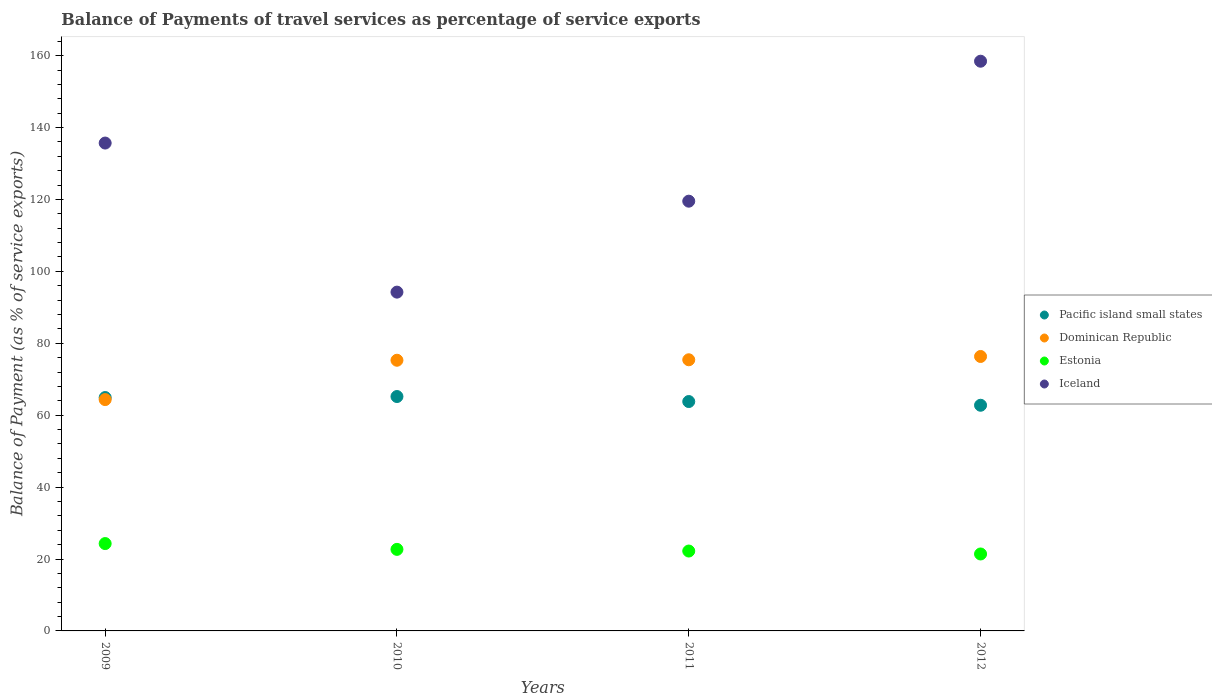Is the number of dotlines equal to the number of legend labels?
Your answer should be very brief. Yes. What is the balance of payments of travel services in Pacific island small states in 2012?
Your answer should be very brief. 62.76. Across all years, what is the maximum balance of payments of travel services in Pacific island small states?
Give a very brief answer. 65.19. Across all years, what is the minimum balance of payments of travel services in Dominican Republic?
Provide a succinct answer. 64.34. What is the total balance of payments of travel services in Estonia in the graph?
Provide a short and direct response. 90.59. What is the difference between the balance of payments of travel services in Pacific island small states in 2009 and that in 2011?
Make the answer very short. 1.11. What is the difference between the balance of payments of travel services in Pacific island small states in 2010 and the balance of payments of travel services in Iceland in 2009?
Make the answer very short. -70.5. What is the average balance of payments of travel services in Estonia per year?
Your answer should be compact. 22.65. In the year 2011, what is the difference between the balance of payments of travel services in Pacific island small states and balance of payments of travel services in Estonia?
Give a very brief answer. 41.58. In how many years, is the balance of payments of travel services in Estonia greater than 64 %?
Provide a short and direct response. 0. What is the ratio of the balance of payments of travel services in Dominican Republic in 2010 to that in 2011?
Give a very brief answer. 1. Is the balance of payments of travel services in Estonia in 2010 less than that in 2012?
Your answer should be very brief. No. What is the difference between the highest and the second highest balance of payments of travel services in Iceland?
Offer a terse response. 22.76. What is the difference between the highest and the lowest balance of payments of travel services in Pacific island small states?
Provide a short and direct response. 2.43. In how many years, is the balance of payments of travel services in Iceland greater than the average balance of payments of travel services in Iceland taken over all years?
Ensure brevity in your answer.  2. Is the sum of the balance of payments of travel services in Iceland in 2009 and 2012 greater than the maximum balance of payments of travel services in Dominican Republic across all years?
Provide a succinct answer. Yes. Is it the case that in every year, the sum of the balance of payments of travel services in Iceland and balance of payments of travel services in Estonia  is greater than the sum of balance of payments of travel services in Dominican Republic and balance of payments of travel services in Pacific island small states?
Your answer should be very brief. Yes. Is it the case that in every year, the sum of the balance of payments of travel services in Dominican Republic and balance of payments of travel services in Pacific island small states  is greater than the balance of payments of travel services in Iceland?
Your answer should be very brief. No. Does the balance of payments of travel services in Pacific island small states monotonically increase over the years?
Provide a succinct answer. No. Is the balance of payments of travel services in Dominican Republic strictly greater than the balance of payments of travel services in Estonia over the years?
Your answer should be very brief. Yes. What is the difference between two consecutive major ticks on the Y-axis?
Make the answer very short. 20. Where does the legend appear in the graph?
Keep it short and to the point. Center right. What is the title of the graph?
Ensure brevity in your answer.  Balance of Payments of travel services as percentage of service exports. What is the label or title of the Y-axis?
Offer a very short reply. Balance of Payment (as % of service exports). What is the Balance of Payment (as % of service exports) in Pacific island small states in 2009?
Your response must be concise. 64.91. What is the Balance of Payment (as % of service exports) of Dominican Republic in 2009?
Provide a short and direct response. 64.34. What is the Balance of Payment (as % of service exports) in Estonia in 2009?
Your answer should be compact. 24.29. What is the Balance of Payment (as % of service exports) in Iceland in 2009?
Your answer should be very brief. 135.69. What is the Balance of Payment (as % of service exports) in Pacific island small states in 2010?
Your answer should be very brief. 65.19. What is the Balance of Payment (as % of service exports) in Dominican Republic in 2010?
Make the answer very short. 75.28. What is the Balance of Payment (as % of service exports) of Estonia in 2010?
Keep it short and to the point. 22.68. What is the Balance of Payment (as % of service exports) in Iceland in 2010?
Provide a short and direct response. 94.23. What is the Balance of Payment (as % of service exports) in Pacific island small states in 2011?
Your response must be concise. 63.8. What is the Balance of Payment (as % of service exports) of Dominican Republic in 2011?
Keep it short and to the point. 75.41. What is the Balance of Payment (as % of service exports) in Estonia in 2011?
Your answer should be very brief. 22.22. What is the Balance of Payment (as % of service exports) in Iceland in 2011?
Offer a very short reply. 119.52. What is the Balance of Payment (as % of service exports) in Pacific island small states in 2012?
Your response must be concise. 62.76. What is the Balance of Payment (as % of service exports) in Dominican Republic in 2012?
Your response must be concise. 76.33. What is the Balance of Payment (as % of service exports) of Estonia in 2012?
Your answer should be very brief. 21.4. What is the Balance of Payment (as % of service exports) in Iceland in 2012?
Make the answer very short. 158.45. Across all years, what is the maximum Balance of Payment (as % of service exports) in Pacific island small states?
Provide a short and direct response. 65.19. Across all years, what is the maximum Balance of Payment (as % of service exports) in Dominican Republic?
Provide a short and direct response. 76.33. Across all years, what is the maximum Balance of Payment (as % of service exports) of Estonia?
Provide a succinct answer. 24.29. Across all years, what is the maximum Balance of Payment (as % of service exports) in Iceland?
Make the answer very short. 158.45. Across all years, what is the minimum Balance of Payment (as % of service exports) of Pacific island small states?
Offer a very short reply. 62.76. Across all years, what is the minimum Balance of Payment (as % of service exports) of Dominican Republic?
Give a very brief answer. 64.34. Across all years, what is the minimum Balance of Payment (as % of service exports) in Estonia?
Your answer should be very brief. 21.4. Across all years, what is the minimum Balance of Payment (as % of service exports) of Iceland?
Give a very brief answer. 94.23. What is the total Balance of Payment (as % of service exports) of Pacific island small states in the graph?
Ensure brevity in your answer.  256.65. What is the total Balance of Payment (as % of service exports) of Dominican Republic in the graph?
Offer a very short reply. 291.36. What is the total Balance of Payment (as % of service exports) of Estonia in the graph?
Give a very brief answer. 90.59. What is the total Balance of Payment (as % of service exports) in Iceland in the graph?
Offer a terse response. 507.88. What is the difference between the Balance of Payment (as % of service exports) of Pacific island small states in 2009 and that in 2010?
Offer a very short reply. -0.28. What is the difference between the Balance of Payment (as % of service exports) of Dominican Republic in 2009 and that in 2010?
Provide a succinct answer. -10.94. What is the difference between the Balance of Payment (as % of service exports) in Estonia in 2009 and that in 2010?
Your answer should be compact. 1.61. What is the difference between the Balance of Payment (as % of service exports) of Iceland in 2009 and that in 2010?
Your answer should be compact. 41.46. What is the difference between the Balance of Payment (as % of service exports) of Pacific island small states in 2009 and that in 2011?
Offer a very short reply. 1.11. What is the difference between the Balance of Payment (as % of service exports) of Dominican Republic in 2009 and that in 2011?
Provide a short and direct response. -11.07. What is the difference between the Balance of Payment (as % of service exports) in Estonia in 2009 and that in 2011?
Provide a succinct answer. 2.08. What is the difference between the Balance of Payment (as % of service exports) of Iceland in 2009 and that in 2011?
Ensure brevity in your answer.  16.17. What is the difference between the Balance of Payment (as % of service exports) of Pacific island small states in 2009 and that in 2012?
Your answer should be compact. 2.14. What is the difference between the Balance of Payment (as % of service exports) in Dominican Republic in 2009 and that in 2012?
Your answer should be very brief. -11.99. What is the difference between the Balance of Payment (as % of service exports) in Estonia in 2009 and that in 2012?
Give a very brief answer. 2.89. What is the difference between the Balance of Payment (as % of service exports) of Iceland in 2009 and that in 2012?
Your response must be concise. -22.76. What is the difference between the Balance of Payment (as % of service exports) of Pacific island small states in 2010 and that in 2011?
Your response must be concise. 1.4. What is the difference between the Balance of Payment (as % of service exports) in Dominican Republic in 2010 and that in 2011?
Offer a terse response. -0.13. What is the difference between the Balance of Payment (as % of service exports) in Estonia in 2010 and that in 2011?
Give a very brief answer. 0.46. What is the difference between the Balance of Payment (as % of service exports) of Iceland in 2010 and that in 2011?
Keep it short and to the point. -25.3. What is the difference between the Balance of Payment (as % of service exports) in Pacific island small states in 2010 and that in 2012?
Your response must be concise. 2.43. What is the difference between the Balance of Payment (as % of service exports) of Dominican Republic in 2010 and that in 2012?
Ensure brevity in your answer.  -1.05. What is the difference between the Balance of Payment (as % of service exports) of Estonia in 2010 and that in 2012?
Provide a short and direct response. 1.28. What is the difference between the Balance of Payment (as % of service exports) in Iceland in 2010 and that in 2012?
Your answer should be very brief. -64.22. What is the difference between the Balance of Payment (as % of service exports) of Pacific island small states in 2011 and that in 2012?
Your answer should be very brief. 1.03. What is the difference between the Balance of Payment (as % of service exports) in Dominican Republic in 2011 and that in 2012?
Make the answer very short. -0.92. What is the difference between the Balance of Payment (as % of service exports) of Estonia in 2011 and that in 2012?
Provide a succinct answer. 0.82. What is the difference between the Balance of Payment (as % of service exports) in Iceland in 2011 and that in 2012?
Give a very brief answer. -38.93. What is the difference between the Balance of Payment (as % of service exports) of Pacific island small states in 2009 and the Balance of Payment (as % of service exports) of Dominican Republic in 2010?
Offer a terse response. -10.37. What is the difference between the Balance of Payment (as % of service exports) in Pacific island small states in 2009 and the Balance of Payment (as % of service exports) in Estonia in 2010?
Make the answer very short. 42.23. What is the difference between the Balance of Payment (as % of service exports) in Pacific island small states in 2009 and the Balance of Payment (as % of service exports) in Iceland in 2010?
Your answer should be very brief. -29.32. What is the difference between the Balance of Payment (as % of service exports) in Dominican Republic in 2009 and the Balance of Payment (as % of service exports) in Estonia in 2010?
Your response must be concise. 41.66. What is the difference between the Balance of Payment (as % of service exports) in Dominican Republic in 2009 and the Balance of Payment (as % of service exports) in Iceland in 2010?
Your answer should be very brief. -29.89. What is the difference between the Balance of Payment (as % of service exports) of Estonia in 2009 and the Balance of Payment (as % of service exports) of Iceland in 2010?
Provide a succinct answer. -69.93. What is the difference between the Balance of Payment (as % of service exports) in Pacific island small states in 2009 and the Balance of Payment (as % of service exports) in Dominican Republic in 2011?
Offer a very short reply. -10.51. What is the difference between the Balance of Payment (as % of service exports) in Pacific island small states in 2009 and the Balance of Payment (as % of service exports) in Estonia in 2011?
Offer a terse response. 42.69. What is the difference between the Balance of Payment (as % of service exports) in Pacific island small states in 2009 and the Balance of Payment (as % of service exports) in Iceland in 2011?
Provide a short and direct response. -54.62. What is the difference between the Balance of Payment (as % of service exports) in Dominican Republic in 2009 and the Balance of Payment (as % of service exports) in Estonia in 2011?
Keep it short and to the point. 42.12. What is the difference between the Balance of Payment (as % of service exports) in Dominican Republic in 2009 and the Balance of Payment (as % of service exports) in Iceland in 2011?
Ensure brevity in your answer.  -55.18. What is the difference between the Balance of Payment (as % of service exports) of Estonia in 2009 and the Balance of Payment (as % of service exports) of Iceland in 2011?
Your response must be concise. -95.23. What is the difference between the Balance of Payment (as % of service exports) in Pacific island small states in 2009 and the Balance of Payment (as % of service exports) in Dominican Republic in 2012?
Your answer should be compact. -11.42. What is the difference between the Balance of Payment (as % of service exports) in Pacific island small states in 2009 and the Balance of Payment (as % of service exports) in Estonia in 2012?
Keep it short and to the point. 43.51. What is the difference between the Balance of Payment (as % of service exports) of Pacific island small states in 2009 and the Balance of Payment (as % of service exports) of Iceland in 2012?
Provide a succinct answer. -93.54. What is the difference between the Balance of Payment (as % of service exports) in Dominican Republic in 2009 and the Balance of Payment (as % of service exports) in Estonia in 2012?
Make the answer very short. 42.94. What is the difference between the Balance of Payment (as % of service exports) of Dominican Republic in 2009 and the Balance of Payment (as % of service exports) of Iceland in 2012?
Make the answer very short. -94.11. What is the difference between the Balance of Payment (as % of service exports) of Estonia in 2009 and the Balance of Payment (as % of service exports) of Iceland in 2012?
Your answer should be compact. -134.15. What is the difference between the Balance of Payment (as % of service exports) of Pacific island small states in 2010 and the Balance of Payment (as % of service exports) of Dominican Republic in 2011?
Make the answer very short. -10.22. What is the difference between the Balance of Payment (as % of service exports) in Pacific island small states in 2010 and the Balance of Payment (as % of service exports) in Estonia in 2011?
Provide a succinct answer. 42.97. What is the difference between the Balance of Payment (as % of service exports) in Pacific island small states in 2010 and the Balance of Payment (as % of service exports) in Iceland in 2011?
Keep it short and to the point. -54.33. What is the difference between the Balance of Payment (as % of service exports) in Dominican Republic in 2010 and the Balance of Payment (as % of service exports) in Estonia in 2011?
Offer a very short reply. 53.06. What is the difference between the Balance of Payment (as % of service exports) of Dominican Republic in 2010 and the Balance of Payment (as % of service exports) of Iceland in 2011?
Your answer should be compact. -44.24. What is the difference between the Balance of Payment (as % of service exports) of Estonia in 2010 and the Balance of Payment (as % of service exports) of Iceland in 2011?
Offer a very short reply. -96.84. What is the difference between the Balance of Payment (as % of service exports) of Pacific island small states in 2010 and the Balance of Payment (as % of service exports) of Dominican Republic in 2012?
Offer a terse response. -11.14. What is the difference between the Balance of Payment (as % of service exports) in Pacific island small states in 2010 and the Balance of Payment (as % of service exports) in Estonia in 2012?
Offer a terse response. 43.79. What is the difference between the Balance of Payment (as % of service exports) in Pacific island small states in 2010 and the Balance of Payment (as % of service exports) in Iceland in 2012?
Provide a short and direct response. -93.26. What is the difference between the Balance of Payment (as % of service exports) in Dominican Republic in 2010 and the Balance of Payment (as % of service exports) in Estonia in 2012?
Make the answer very short. 53.88. What is the difference between the Balance of Payment (as % of service exports) of Dominican Republic in 2010 and the Balance of Payment (as % of service exports) of Iceland in 2012?
Provide a succinct answer. -83.17. What is the difference between the Balance of Payment (as % of service exports) of Estonia in 2010 and the Balance of Payment (as % of service exports) of Iceland in 2012?
Give a very brief answer. -135.77. What is the difference between the Balance of Payment (as % of service exports) of Pacific island small states in 2011 and the Balance of Payment (as % of service exports) of Dominican Republic in 2012?
Provide a short and direct response. -12.53. What is the difference between the Balance of Payment (as % of service exports) of Pacific island small states in 2011 and the Balance of Payment (as % of service exports) of Estonia in 2012?
Your answer should be compact. 42.39. What is the difference between the Balance of Payment (as % of service exports) of Pacific island small states in 2011 and the Balance of Payment (as % of service exports) of Iceland in 2012?
Give a very brief answer. -94.65. What is the difference between the Balance of Payment (as % of service exports) in Dominican Republic in 2011 and the Balance of Payment (as % of service exports) in Estonia in 2012?
Keep it short and to the point. 54.01. What is the difference between the Balance of Payment (as % of service exports) of Dominican Republic in 2011 and the Balance of Payment (as % of service exports) of Iceland in 2012?
Your answer should be compact. -83.04. What is the difference between the Balance of Payment (as % of service exports) in Estonia in 2011 and the Balance of Payment (as % of service exports) in Iceland in 2012?
Your answer should be very brief. -136.23. What is the average Balance of Payment (as % of service exports) of Pacific island small states per year?
Provide a short and direct response. 64.16. What is the average Balance of Payment (as % of service exports) of Dominican Republic per year?
Keep it short and to the point. 72.84. What is the average Balance of Payment (as % of service exports) in Estonia per year?
Your answer should be compact. 22.65. What is the average Balance of Payment (as % of service exports) of Iceland per year?
Offer a very short reply. 126.97. In the year 2009, what is the difference between the Balance of Payment (as % of service exports) in Pacific island small states and Balance of Payment (as % of service exports) in Dominican Republic?
Give a very brief answer. 0.57. In the year 2009, what is the difference between the Balance of Payment (as % of service exports) in Pacific island small states and Balance of Payment (as % of service exports) in Estonia?
Your answer should be very brief. 40.61. In the year 2009, what is the difference between the Balance of Payment (as % of service exports) in Pacific island small states and Balance of Payment (as % of service exports) in Iceland?
Ensure brevity in your answer.  -70.78. In the year 2009, what is the difference between the Balance of Payment (as % of service exports) of Dominican Republic and Balance of Payment (as % of service exports) of Estonia?
Keep it short and to the point. 40.05. In the year 2009, what is the difference between the Balance of Payment (as % of service exports) of Dominican Republic and Balance of Payment (as % of service exports) of Iceland?
Offer a terse response. -71.35. In the year 2009, what is the difference between the Balance of Payment (as % of service exports) of Estonia and Balance of Payment (as % of service exports) of Iceland?
Give a very brief answer. -111.39. In the year 2010, what is the difference between the Balance of Payment (as % of service exports) of Pacific island small states and Balance of Payment (as % of service exports) of Dominican Republic?
Provide a succinct answer. -10.09. In the year 2010, what is the difference between the Balance of Payment (as % of service exports) of Pacific island small states and Balance of Payment (as % of service exports) of Estonia?
Provide a short and direct response. 42.51. In the year 2010, what is the difference between the Balance of Payment (as % of service exports) in Pacific island small states and Balance of Payment (as % of service exports) in Iceland?
Your response must be concise. -29.04. In the year 2010, what is the difference between the Balance of Payment (as % of service exports) of Dominican Republic and Balance of Payment (as % of service exports) of Estonia?
Provide a short and direct response. 52.6. In the year 2010, what is the difference between the Balance of Payment (as % of service exports) of Dominican Republic and Balance of Payment (as % of service exports) of Iceland?
Make the answer very short. -18.95. In the year 2010, what is the difference between the Balance of Payment (as % of service exports) in Estonia and Balance of Payment (as % of service exports) in Iceland?
Keep it short and to the point. -71.55. In the year 2011, what is the difference between the Balance of Payment (as % of service exports) in Pacific island small states and Balance of Payment (as % of service exports) in Dominican Republic?
Your response must be concise. -11.62. In the year 2011, what is the difference between the Balance of Payment (as % of service exports) in Pacific island small states and Balance of Payment (as % of service exports) in Estonia?
Provide a succinct answer. 41.58. In the year 2011, what is the difference between the Balance of Payment (as % of service exports) of Pacific island small states and Balance of Payment (as % of service exports) of Iceland?
Keep it short and to the point. -55.73. In the year 2011, what is the difference between the Balance of Payment (as % of service exports) in Dominican Republic and Balance of Payment (as % of service exports) in Estonia?
Keep it short and to the point. 53.19. In the year 2011, what is the difference between the Balance of Payment (as % of service exports) in Dominican Republic and Balance of Payment (as % of service exports) in Iceland?
Keep it short and to the point. -44.11. In the year 2011, what is the difference between the Balance of Payment (as % of service exports) in Estonia and Balance of Payment (as % of service exports) in Iceland?
Provide a succinct answer. -97.3. In the year 2012, what is the difference between the Balance of Payment (as % of service exports) of Pacific island small states and Balance of Payment (as % of service exports) of Dominican Republic?
Give a very brief answer. -13.57. In the year 2012, what is the difference between the Balance of Payment (as % of service exports) of Pacific island small states and Balance of Payment (as % of service exports) of Estonia?
Your answer should be compact. 41.36. In the year 2012, what is the difference between the Balance of Payment (as % of service exports) of Pacific island small states and Balance of Payment (as % of service exports) of Iceland?
Give a very brief answer. -95.68. In the year 2012, what is the difference between the Balance of Payment (as % of service exports) in Dominican Republic and Balance of Payment (as % of service exports) in Estonia?
Make the answer very short. 54.93. In the year 2012, what is the difference between the Balance of Payment (as % of service exports) in Dominican Republic and Balance of Payment (as % of service exports) in Iceland?
Provide a short and direct response. -82.12. In the year 2012, what is the difference between the Balance of Payment (as % of service exports) of Estonia and Balance of Payment (as % of service exports) of Iceland?
Keep it short and to the point. -137.05. What is the ratio of the Balance of Payment (as % of service exports) of Dominican Republic in 2009 to that in 2010?
Make the answer very short. 0.85. What is the ratio of the Balance of Payment (as % of service exports) in Estonia in 2009 to that in 2010?
Offer a terse response. 1.07. What is the ratio of the Balance of Payment (as % of service exports) in Iceland in 2009 to that in 2010?
Offer a very short reply. 1.44. What is the ratio of the Balance of Payment (as % of service exports) in Pacific island small states in 2009 to that in 2011?
Your response must be concise. 1.02. What is the ratio of the Balance of Payment (as % of service exports) in Dominican Republic in 2009 to that in 2011?
Make the answer very short. 0.85. What is the ratio of the Balance of Payment (as % of service exports) in Estonia in 2009 to that in 2011?
Keep it short and to the point. 1.09. What is the ratio of the Balance of Payment (as % of service exports) of Iceland in 2009 to that in 2011?
Your response must be concise. 1.14. What is the ratio of the Balance of Payment (as % of service exports) of Pacific island small states in 2009 to that in 2012?
Your response must be concise. 1.03. What is the ratio of the Balance of Payment (as % of service exports) in Dominican Republic in 2009 to that in 2012?
Provide a short and direct response. 0.84. What is the ratio of the Balance of Payment (as % of service exports) in Estonia in 2009 to that in 2012?
Your response must be concise. 1.14. What is the ratio of the Balance of Payment (as % of service exports) in Iceland in 2009 to that in 2012?
Your answer should be compact. 0.86. What is the ratio of the Balance of Payment (as % of service exports) in Pacific island small states in 2010 to that in 2011?
Provide a succinct answer. 1.02. What is the ratio of the Balance of Payment (as % of service exports) of Estonia in 2010 to that in 2011?
Offer a very short reply. 1.02. What is the ratio of the Balance of Payment (as % of service exports) in Iceland in 2010 to that in 2011?
Offer a terse response. 0.79. What is the ratio of the Balance of Payment (as % of service exports) of Pacific island small states in 2010 to that in 2012?
Provide a short and direct response. 1.04. What is the ratio of the Balance of Payment (as % of service exports) of Dominican Republic in 2010 to that in 2012?
Make the answer very short. 0.99. What is the ratio of the Balance of Payment (as % of service exports) in Estonia in 2010 to that in 2012?
Keep it short and to the point. 1.06. What is the ratio of the Balance of Payment (as % of service exports) in Iceland in 2010 to that in 2012?
Provide a succinct answer. 0.59. What is the ratio of the Balance of Payment (as % of service exports) of Pacific island small states in 2011 to that in 2012?
Keep it short and to the point. 1.02. What is the ratio of the Balance of Payment (as % of service exports) of Dominican Republic in 2011 to that in 2012?
Ensure brevity in your answer.  0.99. What is the ratio of the Balance of Payment (as % of service exports) of Estonia in 2011 to that in 2012?
Make the answer very short. 1.04. What is the ratio of the Balance of Payment (as % of service exports) in Iceland in 2011 to that in 2012?
Give a very brief answer. 0.75. What is the difference between the highest and the second highest Balance of Payment (as % of service exports) in Pacific island small states?
Provide a short and direct response. 0.28. What is the difference between the highest and the second highest Balance of Payment (as % of service exports) of Dominican Republic?
Offer a very short reply. 0.92. What is the difference between the highest and the second highest Balance of Payment (as % of service exports) in Estonia?
Offer a very short reply. 1.61. What is the difference between the highest and the second highest Balance of Payment (as % of service exports) of Iceland?
Offer a terse response. 22.76. What is the difference between the highest and the lowest Balance of Payment (as % of service exports) of Pacific island small states?
Make the answer very short. 2.43. What is the difference between the highest and the lowest Balance of Payment (as % of service exports) in Dominican Republic?
Offer a terse response. 11.99. What is the difference between the highest and the lowest Balance of Payment (as % of service exports) in Estonia?
Provide a short and direct response. 2.89. What is the difference between the highest and the lowest Balance of Payment (as % of service exports) in Iceland?
Keep it short and to the point. 64.22. 